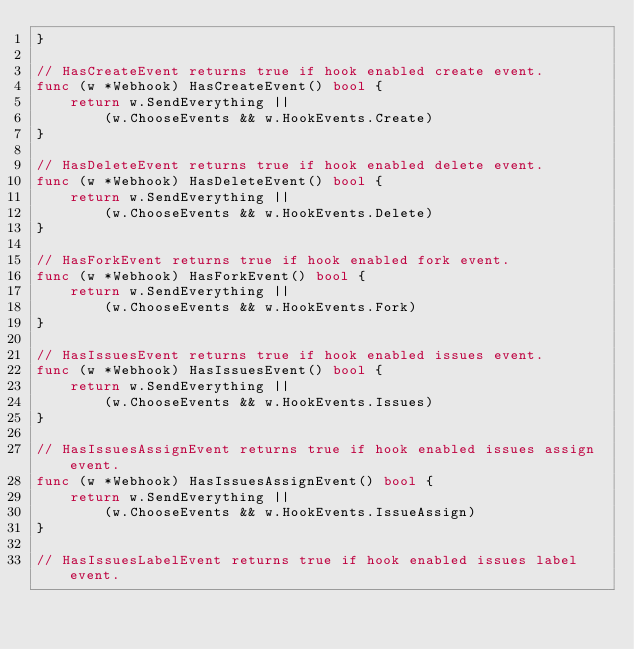Convert code to text. <code><loc_0><loc_0><loc_500><loc_500><_Go_>}

// HasCreateEvent returns true if hook enabled create event.
func (w *Webhook) HasCreateEvent() bool {
	return w.SendEverything ||
		(w.ChooseEvents && w.HookEvents.Create)
}

// HasDeleteEvent returns true if hook enabled delete event.
func (w *Webhook) HasDeleteEvent() bool {
	return w.SendEverything ||
		(w.ChooseEvents && w.HookEvents.Delete)
}

// HasForkEvent returns true if hook enabled fork event.
func (w *Webhook) HasForkEvent() bool {
	return w.SendEverything ||
		(w.ChooseEvents && w.HookEvents.Fork)
}

// HasIssuesEvent returns true if hook enabled issues event.
func (w *Webhook) HasIssuesEvent() bool {
	return w.SendEverything ||
		(w.ChooseEvents && w.HookEvents.Issues)
}

// HasIssuesAssignEvent returns true if hook enabled issues assign event.
func (w *Webhook) HasIssuesAssignEvent() bool {
	return w.SendEverything ||
		(w.ChooseEvents && w.HookEvents.IssueAssign)
}

// HasIssuesLabelEvent returns true if hook enabled issues label event.</code> 